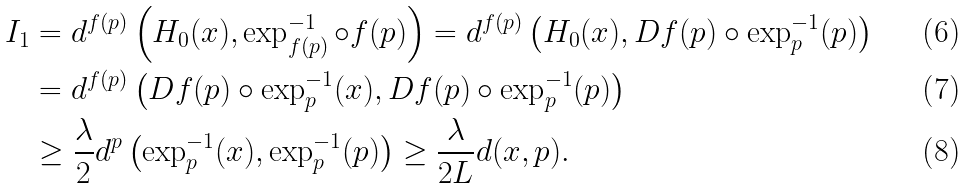Convert formula to latex. <formula><loc_0><loc_0><loc_500><loc_500>I _ { 1 } & = d ^ { f ( p ) } \left ( H _ { 0 } ( x ) , \exp _ { f ( p ) } ^ { - 1 } \circ f ( p ) \right ) = d ^ { f ( p ) } \left ( H _ { 0 } ( x ) , D f ( p ) \circ \exp _ { p } ^ { - 1 } ( p ) \right ) \\ & = d ^ { f ( p ) } \left ( D f ( p ) \circ \exp _ { p } ^ { - 1 } ( x ) , D f ( p ) \circ \exp _ { p } ^ { - 1 } ( p ) \right ) \\ & \geq \frac { \lambda } { 2 } d ^ { p } \left ( \exp _ { p } ^ { - 1 } ( x ) , \exp _ { p } ^ { - 1 } ( p ) \right ) \geq \frac { \lambda } { 2 L } d ( x , p ) .</formula> 